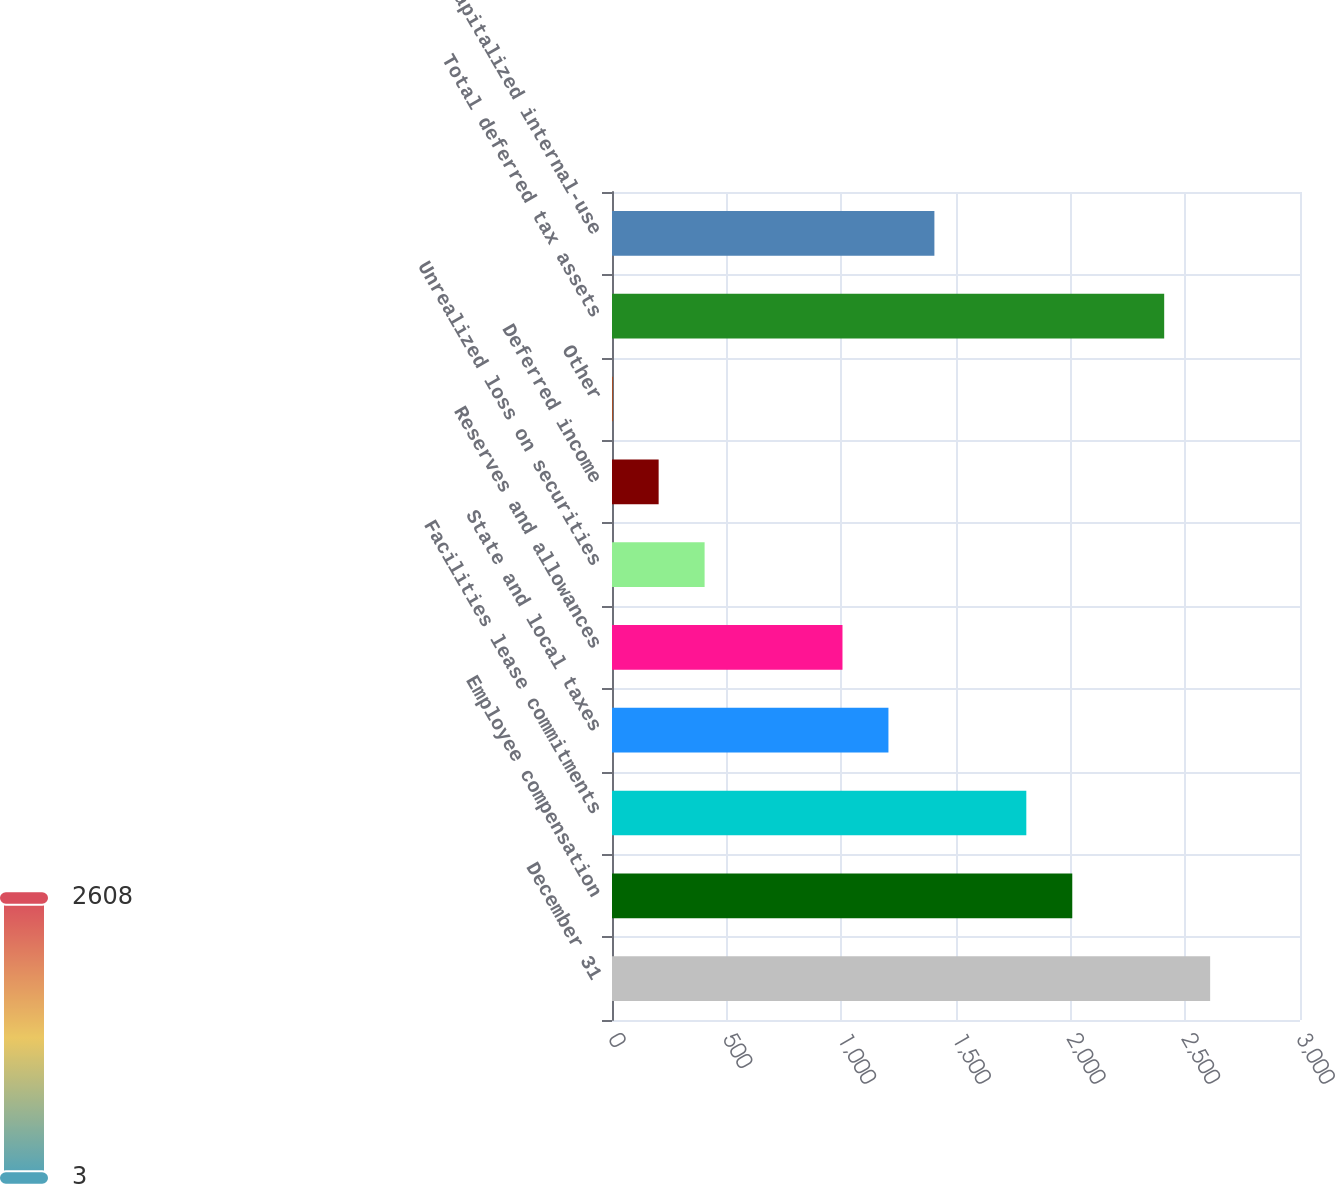Convert chart to OTSL. <chart><loc_0><loc_0><loc_500><loc_500><bar_chart><fcel>December 31<fcel>Employee compensation<fcel>Facilities lease commitments<fcel>State and local taxes<fcel>Reserves and allowances<fcel>Unrealized loss on securities<fcel>Deferred income<fcel>Other<fcel>Total deferred tax assets<fcel>Capitalized internal-use<nl><fcel>2608.2<fcel>2007<fcel>1806.6<fcel>1205.4<fcel>1005<fcel>403.8<fcel>203.4<fcel>3<fcel>2407.8<fcel>1405.8<nl></chart> 